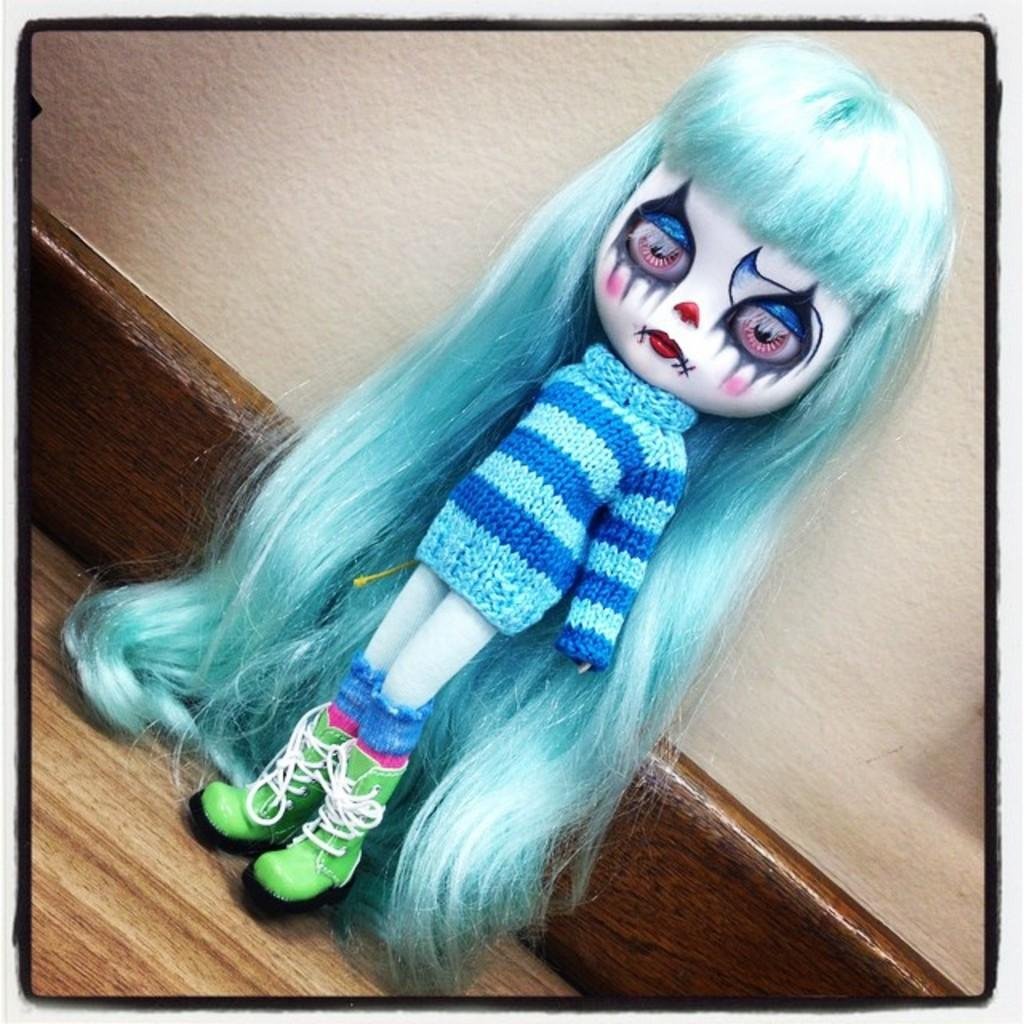What is the main subject of the image? There is a doll in the image. Where is the doll located? The doll is on a table. What can be seen in the background of the image? There is a wall in the background of the image. What type of kettle is visible in the image? There is no kettle present in the image. Can you describe the van parked near the doll in the image? There is no van present in the image; it only features a doll on a table and a wall in the background. 